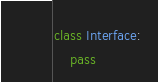<code> <loc_0><loc_0><loc_500><loc_500><_Python_>class Interface:
    pass
</code> 